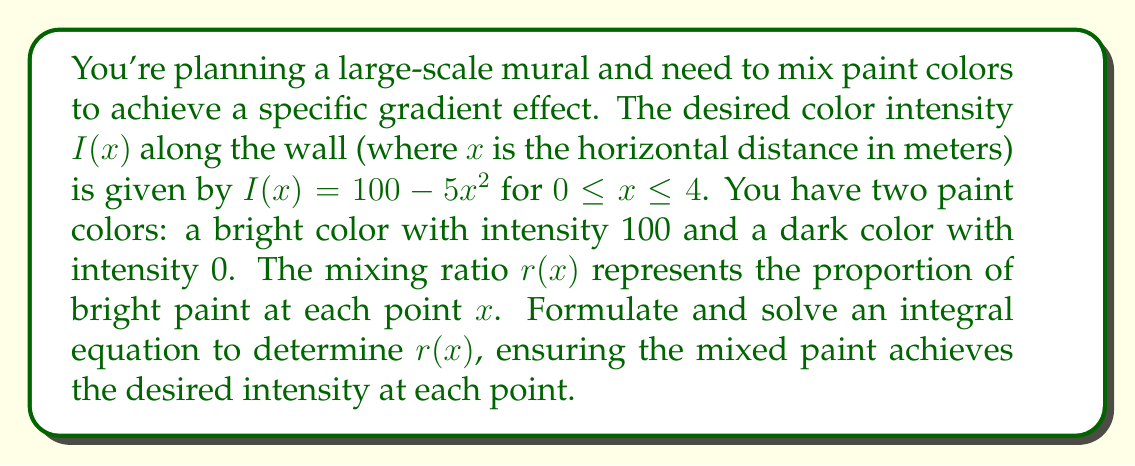What is the answer to this math problem? 1) The intensity at any point $x$ is a linear combination of the two paint intensities, weighted by the mixing ratio:

   $I(x) = 100r(x) + 0(1-r(x)) = 100r(x)$

2) We know that $I(x) = 100 - 5x^2$, so we can equate these:

   $100r(x) = 100 - 5x^2$

3) Solving for $r(x)$:

   $r(x) = 1 - \frac{5x^2}{100} = 1 - 0.05x^2$

4) To verify this solution, we can formulate an integral equation. The average intensity over the interval $[0,4]$ should equal the integral of the desired intensity function divided by the length of the interval:

   $\frac{1}{4}\int_0^4 100r(x)dx = \frac{1}{4}\int_0^4 (100 - 5x^2)dx$

5) Let's solve the right side first:

   $\frac{1}{4}\int_0^4 (100 - 5x^2)dx = \frac{1}{4}[100x - \frac{5x^3}{3}]_0^4 = \frac{1}{4}(400 - \frac{320}{3}) = 80$

6) Now, let's verify the left side using our solution for $r(x)$:

   $\frac{1}{4}\int_0^4 100r(x)dx = \frac{1}{4}\int_0^4 100(1 - 0.05x^2)dx$
   
   $= \frac{100}{4}\int_0^4 (1 - 0.05x^2)dx = 25[x - \frac{0.05x^3}{3}]_0^4$
   
   $= 25(4 - \frac{3.2}{3}) = 25(4 - \frac{16}{15}) = 80$

7) The left side equals the right side, confirming our solution for $r(x)$.
Answer: $r(x) = 1 - 0.05x^2$ 